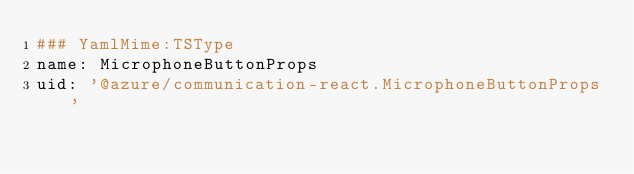<code> <loc_0><loc_0><loc_500><loc_500><_YAML_>### YamlMime:TSType
name: MicrophoneButtonProps
uid: '@azure/communication-react.MicrophoneButtonProps'</code> 